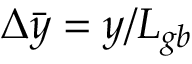<formula> <loc_0><loc_0><loc_500><loc_500>\Delta { \bar { y } } = y / L _ { g b }</formula> 